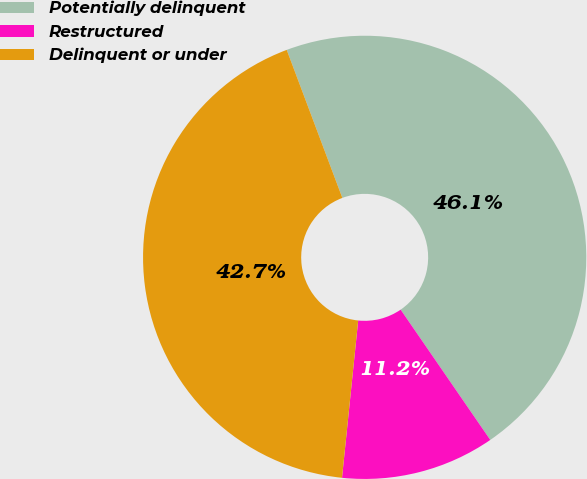Convert chart to OTSL. <chart><loc_0><loc_0><loc_500><loc_500><pie_chart><fcel>Potentially delinquent<fcel>Restructured<fcel>Delinquent or under<nl><fcel>46.13%<fcel>11.22%<fcel>42.65%<nl></chart> 